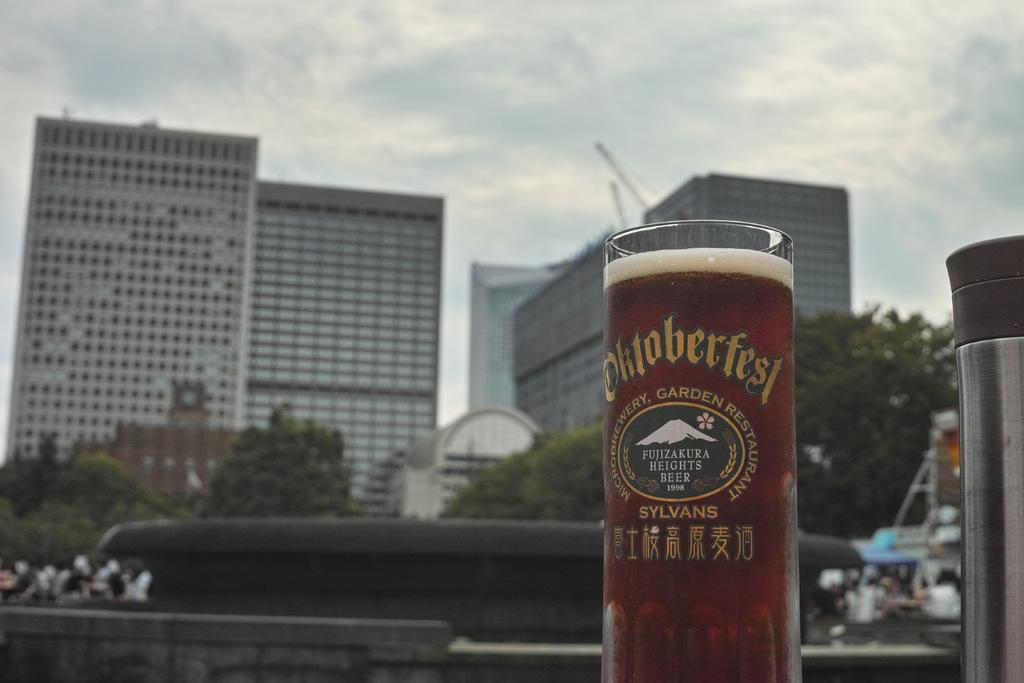<image>
Describe the image concisely. A drinking glass from Octoberfest is sitting outside with buildings behind it. 